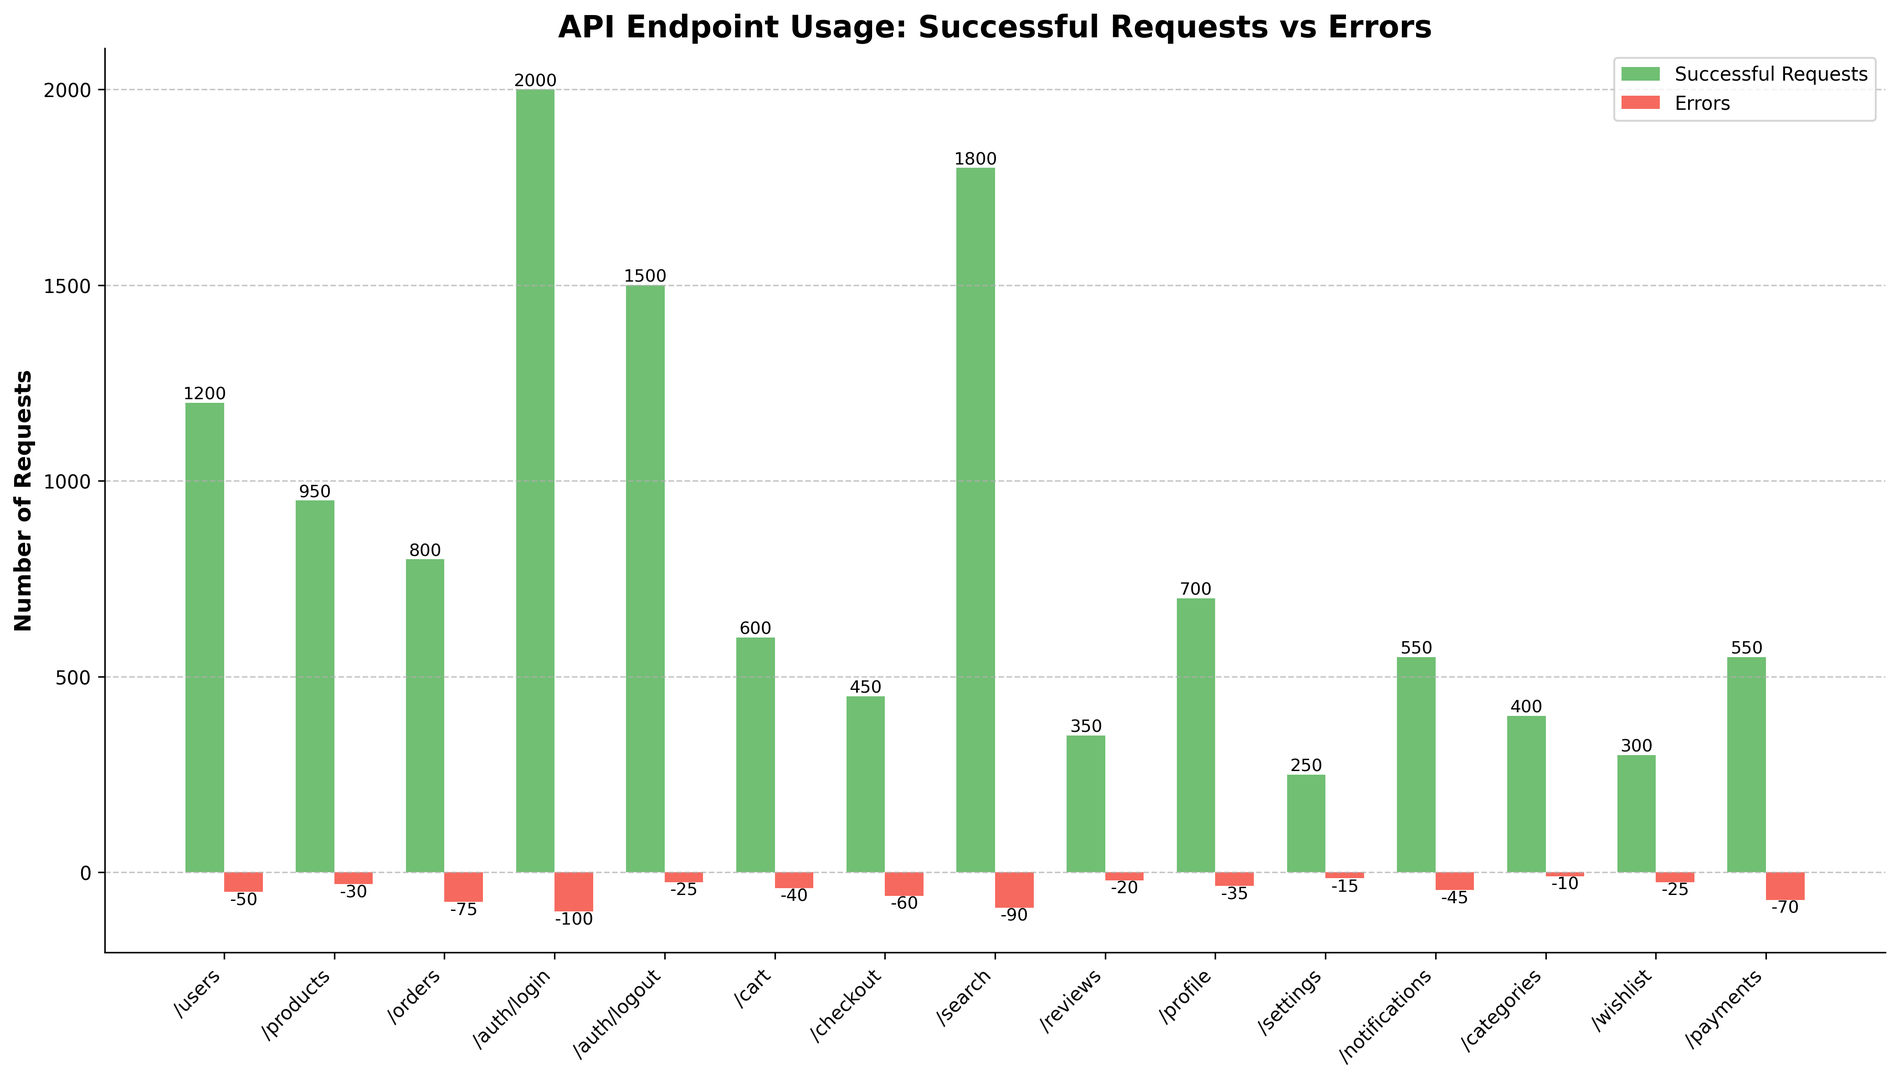Which endpoint has the highest number of successful requests? By looking at the bar chart, we can identify the endpoint with the tallest green bar. The endpoint "/auth/login" has the highest green bar, representing the largest number of successful requests.
Answer: /auth/login Which endpoint has the highest number of errors? We need to identify the endpoint with the tallest red bar in the chart. The endpoint "/auth/login" has the highest red bar, indicating the most errors.
Answer: /auth/login Which endpoint has the lowest number of successful requests? By comparing the heights of the green bars, we can see that the endpoint "/settings" has the shortest green bar.
Answer: /settings What is the total number of errors for all endpoints combined? Add up the values of the red bars for each endpoint: -50 + -30 + -75 + -100 + -25 + -40 + -60 + -90 + -20 + -35 + -15 + -45 + -10 + -25 + -70 = -660.
Answer: -660 Which endpoints have more errors than successful requests? Compare each red bar to its corresponding green bar. The endpoints "/auth/login" and "/search" have red bars extending further below the axis than the green bars extend above it.
Answer: /auth/login, /search How many more successful requests does "/users" have compared to "/products"? Subtract the number of successful requests for "/products" from the number for "/users": 1200 - 950 = 250.
Answer: 250 What color represents errors in the bar chart? The errors are shown in red bars, as indicated in the chart.
Answer: Red What is the average number of successful requests across all endpoints? Sum the successful requests and divide by the number of endpoints: (1200 + 950 + 800 + 2000 + 1500 + 600 + 450 + 1800 + 350 + 700 + 250 + 550 + 400 + 300 + 550) / 15 = 11400 / 15 = 760.
Answer: 760 How many endpoints have more than 1000 successful requests? Count the endpoints with green bars exceeding 1000: "/auth/login", "/auth/logout", and "/search".
Answer: 3 Which endpoint has the smallest absolute number of errors? The smallest magnitude of red bar can be found for "/categories", which has -10 errors.
Answer: /categories 